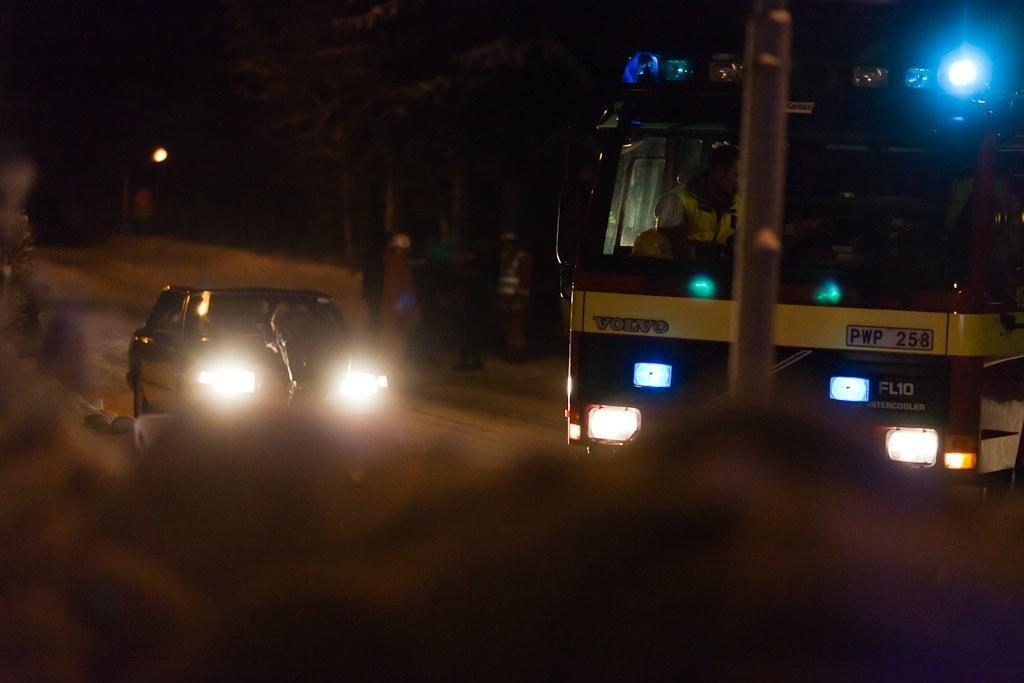Could you give a brief overview of what you see in this image? In this image at the bottom the image is blur but we can see an object. On the right side we can see a person sitting in the vehicle. On the left side we can see a vehicle, few persons and trees. In the background the image is dark but we can see a light. 